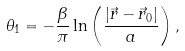<formula> <loc_0><loc_0><loc_500><loc_500>\theta _ { 1 } = - \frac { \beta } { \pi } \ln \left ( \frac { | \vec { r } - \vec { r } _ { 0 } | } { a } \right ) ,</formula> 